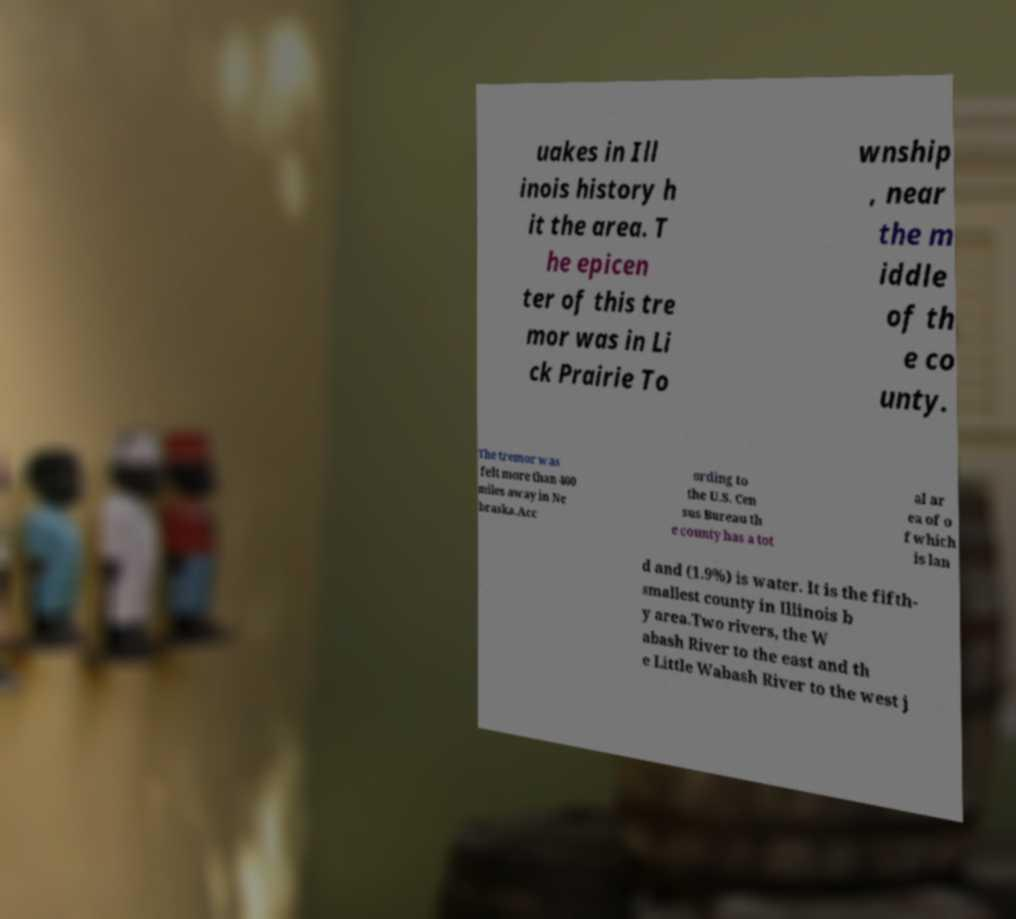For documentation purposes, I need the text within this image transcribed. Could you provide that? uakes in Ill inois history h it the area. T he epicen ter of this tre mor was in Li ck Prairie To wnship , near the m iddle of th e co unty. The tremor was felt more than 400 miles away in Ne braska.Acc ording to the U.S. Cen sus Bureau th e county has a tot al ar ea of o f which is lan d and (1.9%) is water. It is the fifth- smallest county in Illinois b y area.Two rivers, the W abash River to the east and th e Little Wabash River to the west j 